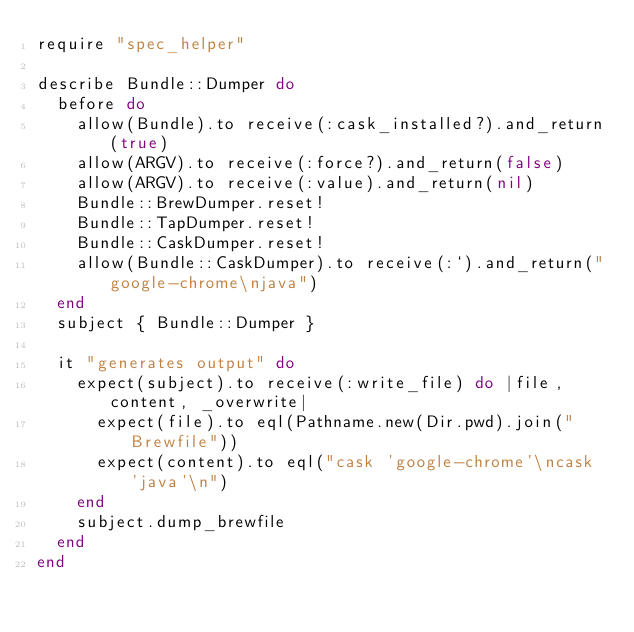Convert code to text. <code><loc_0><loc_0><loc_500><loc_500><_Ruby_>require "spec_helper"

describe Bundle::Dumper do
  before do
    allow(Bundle).to receive(:cask_installed?).and_return(true)
    allow(ARGV).to receive(:force?).and_return(false)
    allow(ARGV).to receive(:value).and_return(nil)
    Bundle::BrewDumper.reset!
    Bundle::TapDumper.reset!
    Bundle::CaskDumper.reset!
    allow(Bundle::CaskDumper).to receive(:`).and_return("google-chrome\njava")
  end
  subject { Bundle::Dumper }

  it "generates output" do
    expect(subject).to receive(:write_file) do |file, content, _overwrite|
      expect(file).to eql(Pathname.new(Dir.pwd).join("Brewfile"))
      expect(content).to eql("cask 'google-chrome'\ncask 'java'\n")
    end
    subject.dump_brewfile
  end
end
</code> 